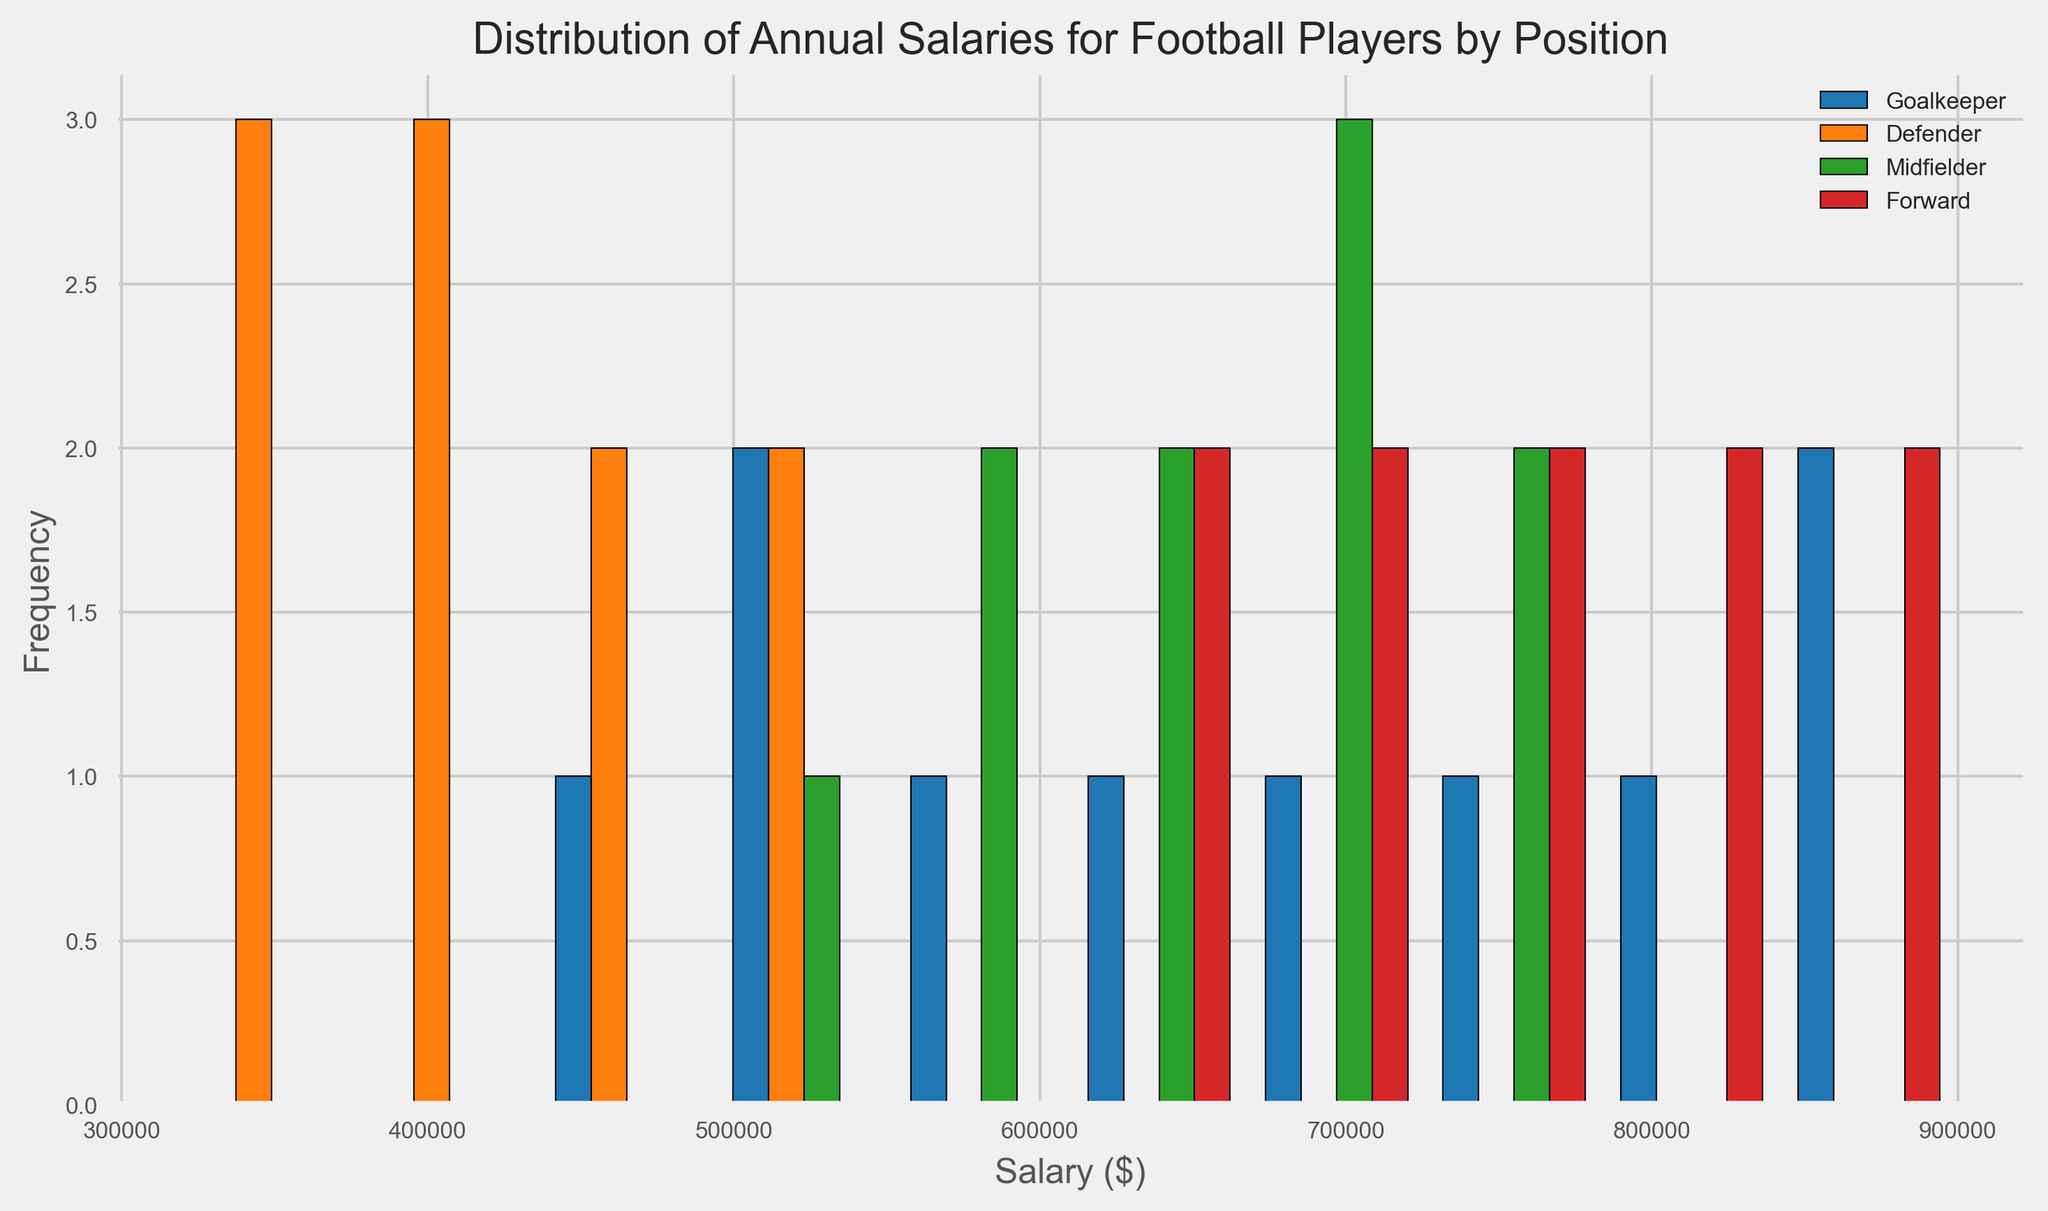What's the median salary for Goalkeepers? Identify the middle value in the sorted list of Goalkeeper salaries. For Goalkeepers, the salaries are [450000, 500000, 530000, 600000, 650000, 700000, 730000, 800000, 850000, 900000]. The middle value between 650000 and 700000 is 675000.
Answer: 675000 Which position has the highest frequency of players in the $600,000 to $700,000 range? Look at the histogram bars for each position within the $600,000 to $700,000 range and compare their heights. Midfielders have the highest bar in this range.
Answer: Midfielder What is the range of salaries for Forwards? The range is the difference between the maximum and minimum salaries of Forwards. The minimum salary is 620000, and the maximum is 890000. So, 890000 - 620000 = 270000.
Answer: 270000 How does the salary distribution for Defenders compare to that of Goalkeepers? Compare the spread of the salary bars for Defenders and Goalkeepers. Defenders have a narrower salary spread centered around lower values compared to the wider spread and higher values for Goalkeepers.
Answer: Goalkeepers have a wider and higher salary distribution Which position has the most variability in salary distribution? Look for the position with the most spread out histogram bars. Goalkeepers have the widest spread, indicating the most variability in their salary distribution.
Answer: Goalkeeper What is the height of the highest bar for each position? Measure the height of the tallest bars for each position in the histogram. For Goalkeepers, it's 2; Defenders, it's 3; Midfielders, it's 2; Forwards, it's 2.
Answer: Goalkeeper: 2, Defender: 3, Midfielder: 2, Forward: 2 Which position has the smallest median salary? Determine the median for each position and compare them. The median values are Goalkeeper: 675000, Defender: 400000, Midfielder: 675000, Forward: 750000. Defenders have the smallest median salary.
Answer: Defender 